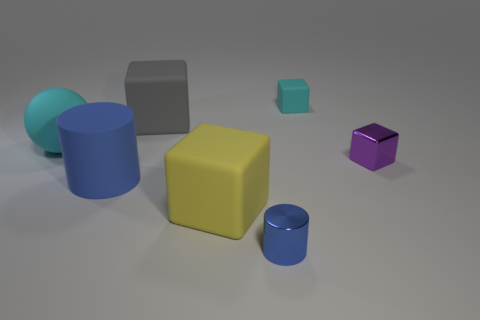There is a matte thing that is to the right of the metallic object that is in front of the purple thing; what shape is it?
Your answer should be compact. Cube. There is a object that is the same color as the big matte ball; what material is it?
Offer a terse response. Rubber. There is a sphere that is made of the same material as the cyan block; what color is it?
Make the answer very short. Cyan. Is there anything else that is the same size as the cyan rubber ball?
Provide a short and direct response. Yes. Do the shiny object on the right side of the tiny blue metallic cylinder and the shiny object that is in front of the big yellow matte object have the same color?
Provide a succinct answer. No. Is the number of big blue cylinders that are to the left of the yellow rubber cube greater than the number of tiny metal things to the right of the purple shiny object?
Keep it short and to the point. Yes. The other big object that is the same shape as the yellow matte object is what color?
Provide a short and direct response. Gray. Is there any other thing that has the same shape as the big yellow matte object?
Provide a short and direct response. Yes. Do the small cyan matte object and the small metal object behind the small blue shiny cylinder have the same shape?
Your answer should be very brief. Yes. What number of other objects are there of the same material as the purple object?
Your answer should be very brief. 1. 